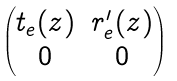Convert formula to latex. <formula><loc_0><loc_0><loc_500><loc_500>\begin{pmatrix} t _ { e } ( z ) & r ^ { \prime } _ { e } ( z ) \\ 0 & 0 \end{pmatrix}</formula> 